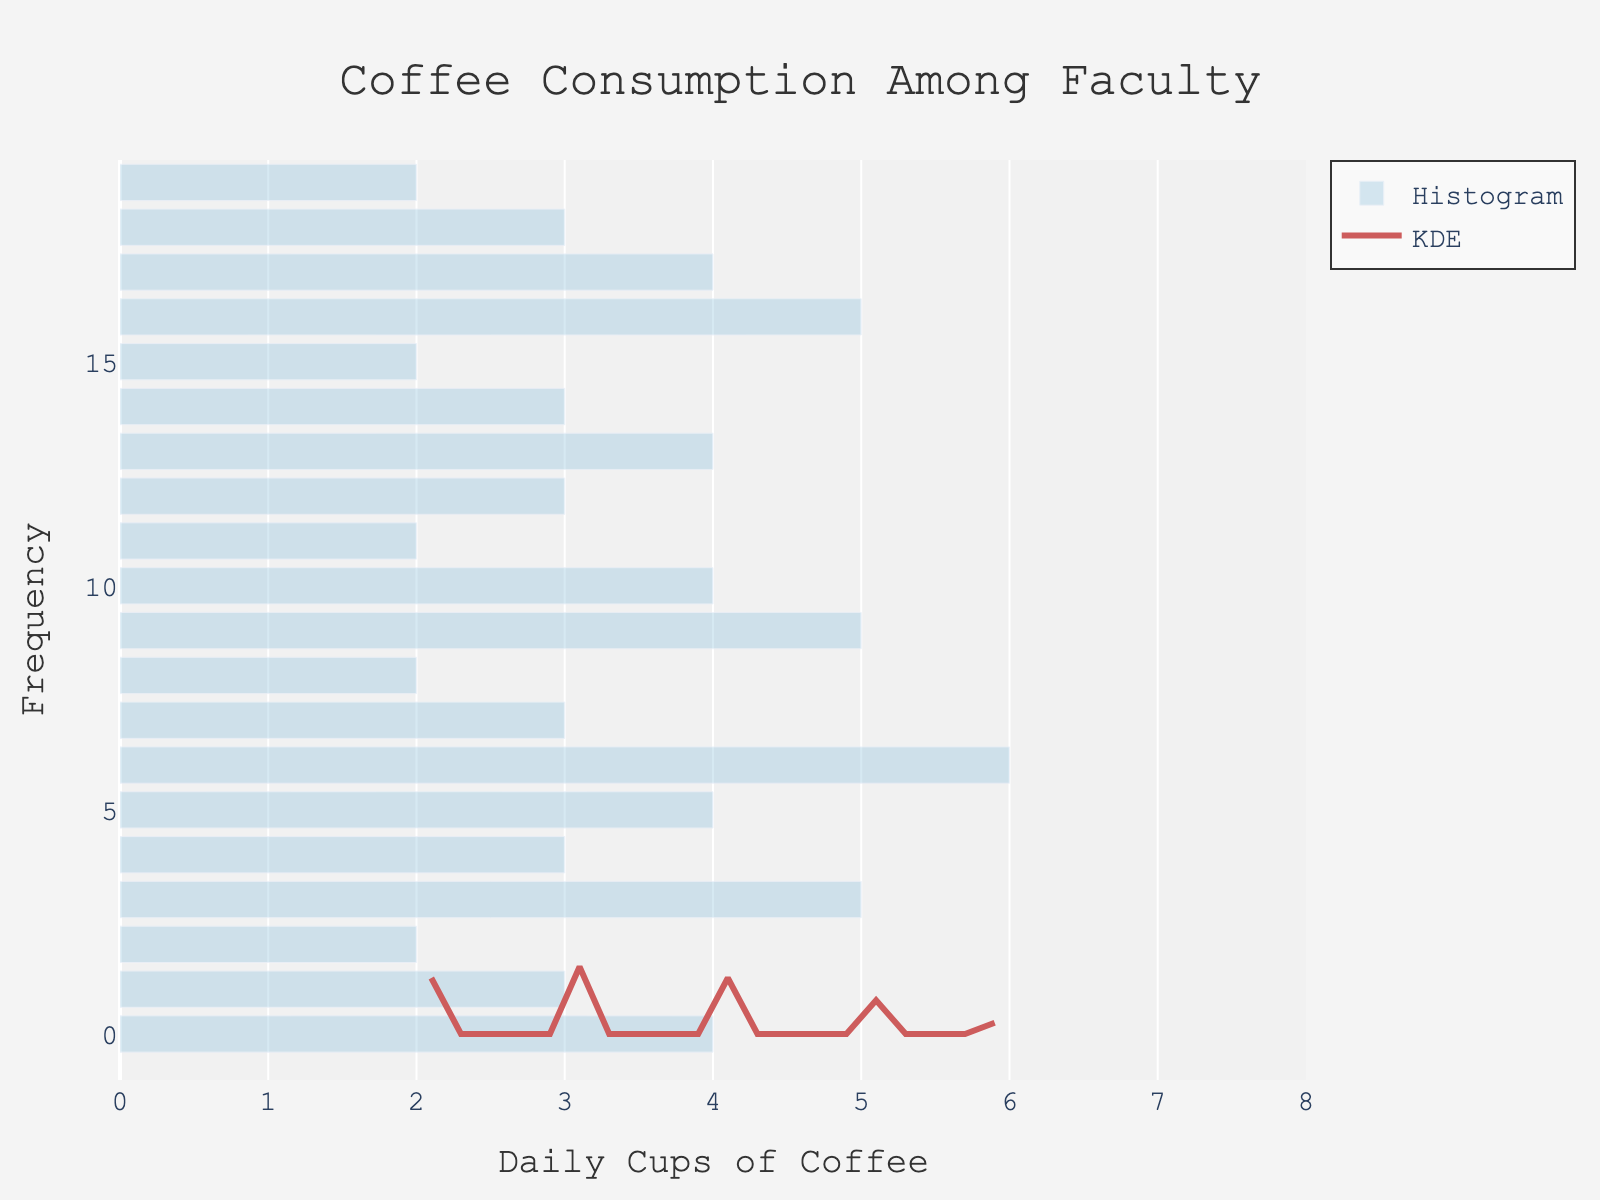What's the title of the figure? The title can be found at the top of the figure.
Answer: Coffee Consumption Among Faculty What does the x-axis represent? The x-axis label indicates what the axis represents by its title.
Answer: Daily Cups of Coffee How many departments reported drinking 4 cups of coffee daily? Look at the histogram bars and identify the height of the bar corresponding to 4 cups of coffee.
Answer: 4 departments Which daily consumption value appears most frequently among the faculty members? Identify the tallest bar in the histogram, which indicates the mode of the dataset.
Answer: 3 cups How smooth is the KDE curve? By examining the KDE trace (density curve), you can see the smoothness by observing the absence of sharp peaks.
Answer: Very smooth Between which two daily coffee consumption values is the KDE curve highest? Look for the peak of the KDE curve and note the range where it is highest.
Answer: Between 2 and 3 cups What is the average daily coffee consumption among faculty members? Add all the daily consumption values and divide by the number of departments: (4+3+2+5+3+4+6+3+2+5+4+2+3+4+3+2+5+4+3+2) / 20 = 3.4 cups.
Answer: 3.4 cups Is the distribution of daily coffee consumption skewed? If so, in which direction? Assess the shape of the histogram and the KDE curve; if it has a longer tail on one side, it indicates skewness.
Answer: No significant skewness Are there any departments that consume more than 5 cups of coffee daily? Check the histogram for any bars above the value of 5 on the x-axis.
Answer: No How many departments consume 2 or fewer cups of coffee daily? Sum the frequencies of the bars corresponding to 2 or fewer cups of coffee.
Answer: 6 departments 